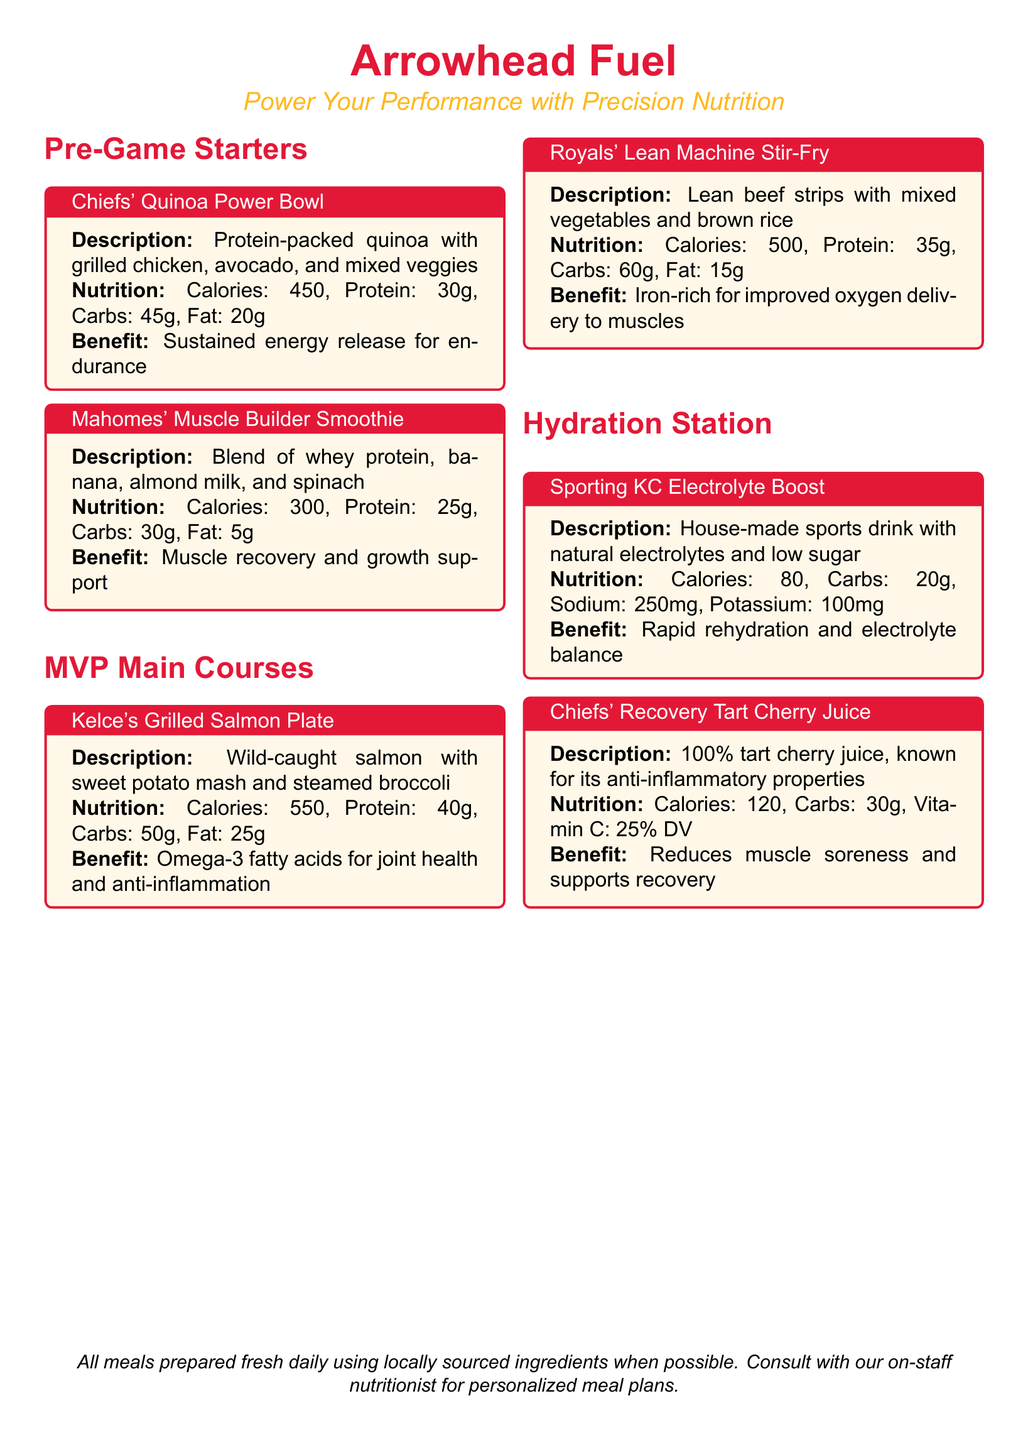What is the calorie count of Chiefs' Quinoa Power Bowl? The calorie count is found in the nutrition section of the dish description, which states 450 calories.
Answer: 450 How many grams of protein does Mahomes' Muscle Builder Smoothie contain? The protein content is listed as 25 grams in the nutrition section of that item.
Answer: 25g What is the main ingredient in Kelce's Grilled Salmon Plate? The main ingredient is specified in the description, which mentions wild-caught salmon.
Answer: Wild-caught salmon What is the benefit of consuming Royals' Lean Machine Stir-Fry? The benefit derives from the nutrition information provided, emphasizing it is iron-rich, aiding oxygen delivery to muscles.
Answer: Iron-rich for improved oxygen delivery to muscles How many carbohydrates are in the Sporting KC Electrolyte Boost? The carbohydrate amount is indicated in the nutrition section as 20 grams.
Answer: 20g What percentage of daily value does Chiefs' Recovery Tart Cherry Juice provide for Vitamin C? The document states that it provides 25% of the daily value for Vitamin C.
Answer: 25% DV Which item is designed for rapid rehydration? This information is derived from the benefit section that details the purpose of the Sporting KC Electrolyte Boost.
Answer: Sporting KC Electrolyte Boost What cooking method is used for the proteins in this menu? The cooking methods can be deduced from the descriptions, which mention grilled for some dishes.
Answer: Grilled How many total dishes are listed in the Pre-Game Starters section? The document lists two dishes in the Pre-Game Starters section.
Answer: 2 